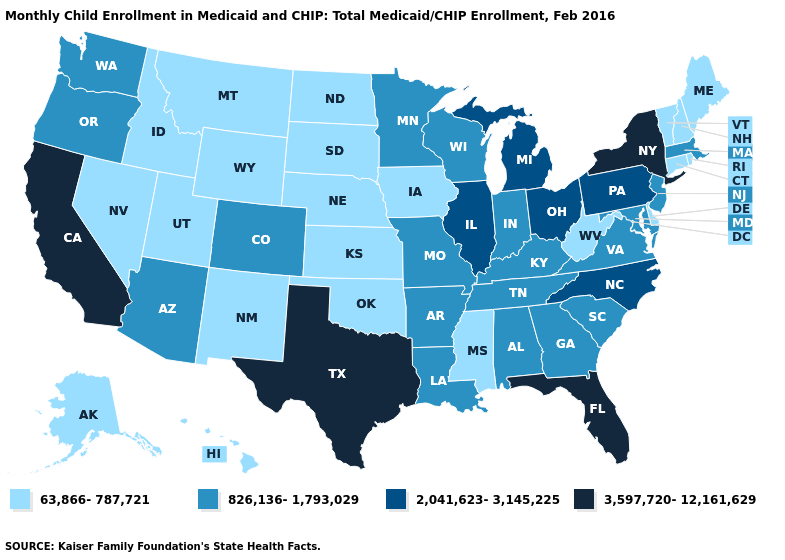What is the value of Hawaii?
Answer briefly. 63,866-787,721. Does California have the highest value in the USA?
Write a very short answer. Yes. Name the states that have a value in the range 826,136-1,793,029?
Concise answer only. Alabama, Arizona, Arkansas, Colorado, Georgia, Indiana, Kentucky, Louisiana, Maryland, Massachusetts, Minnesota, Missouri, New Jersey, Oregon, South Carolina, Tennessee, Virginia, Washington, Wisconsin. Among the states that border Arkansas , does Mississippi have the lowest value?
Write a very short answer. Yes. Among the states that border Nebraska , which have the highest value?
Keep it brief. Colorado, Missouri. Which states have the lowest value in the Northeast?
Answer briefly. Connecticut, Maine, New Hampshire, Rhode Island, Vermont. How many symbols are there in the legend?
Quick response, please. 4. Name the states that have a value in the range 3,597,720-12,161,629?
Keep it brief. California, Florida, New York, Texas. What is the lowest value in the USA?
Answer briefly. 63,866-787,721. Does New York have a lower value than New Jersey?
Answer briefly. No. Name the states that have a value in the range 2,041,623-3,145,225?
Be succinct. Illinois, Michigan, North Carolina, Ohio, Pennsylvania. Name the states that have a value in the range 2,041,623-3,145,225?
Quick response, please. Illinois, Michigan, North Carolina, Ohio, Pennsylvania. Name the states that have a value in the range 2,041,623-3,145,225?
Concise answer only. Illinois, Michigan, North Carolina, Ohio, Pennsylvania. What is the lowest value in the USA?
Be succinct. 63,866-787,721. Which states have the lowest value in the South?
Concise answer only. Delaware, Mississippi, Oklahoma, West Virginia. 